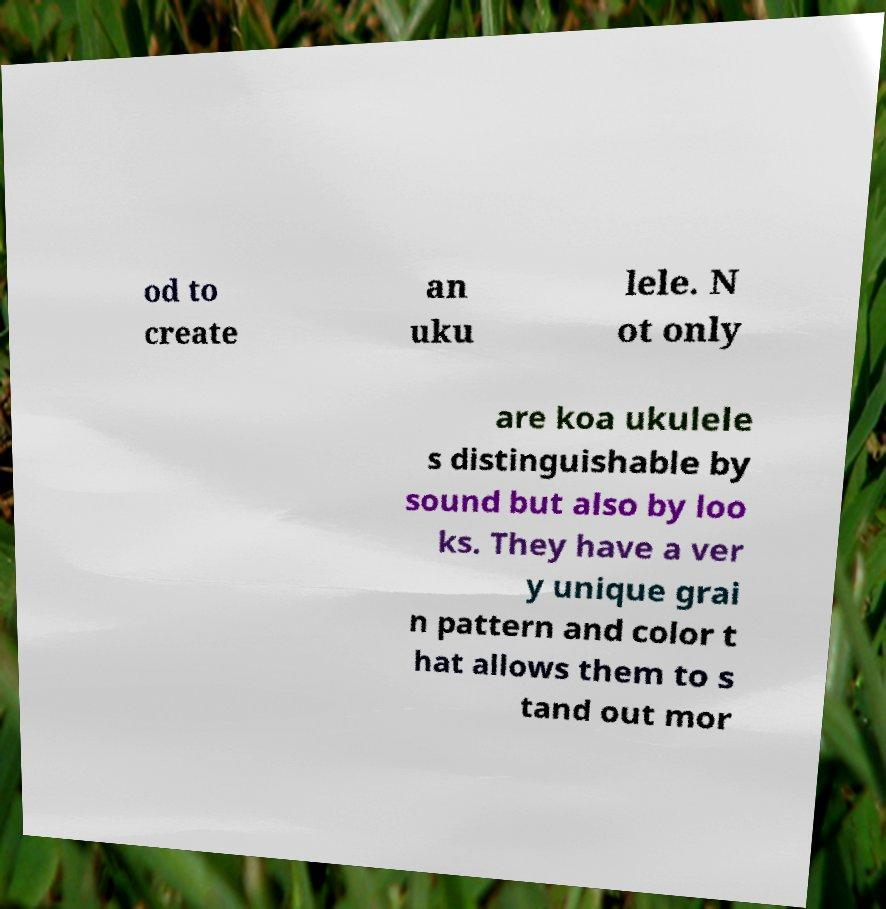For documentation purposes, I need the text within this image transcribed. Could you provide that? od to create an uku lele. N ot only are koa ukulele s distinguishable by sound but also by loo ks. They have a ver y unique grai n pattern and color t hat allows them to s tand out mor 